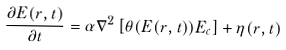Convert formula to latex. <formula><loc_0><loc_0><loc_500><loc_500>\frac { \partial E ( { r } , t ) } { \partial t } = \alpha \nabla ^ { 2 } \left [ \theta ( E ( { r } , t ) ) E _ { c } \right ] + \eta ( { r } , t )</formula> 